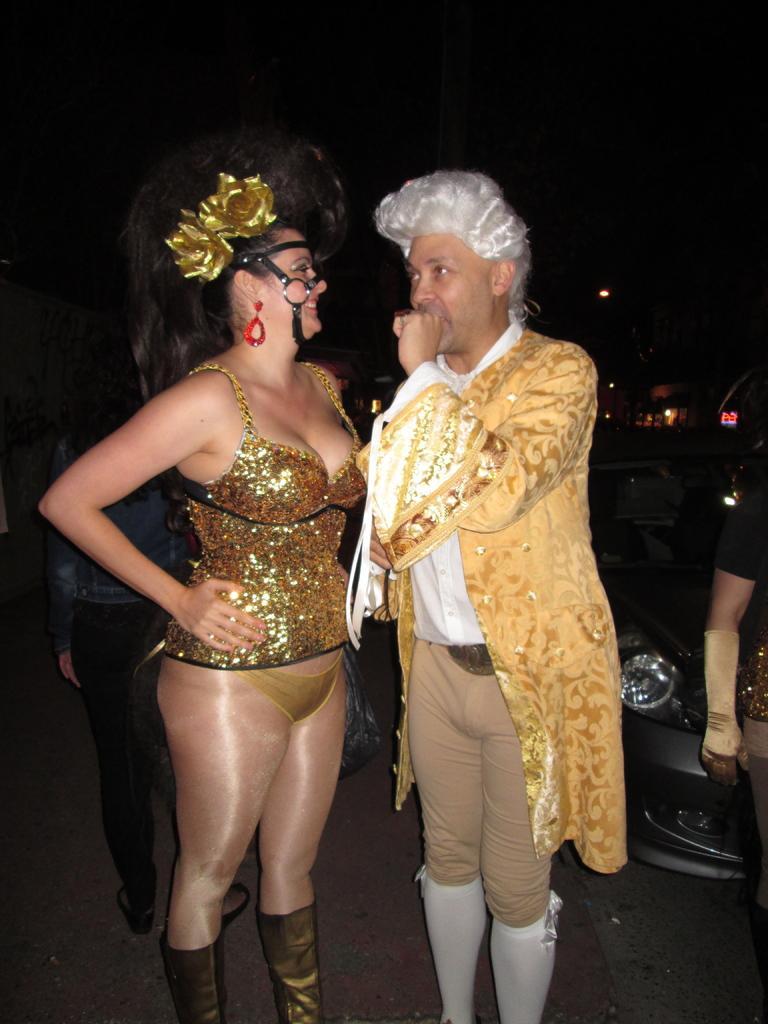Could you give a brief overview of what you see in this image? In this image there are two persons who are standing and on the background there is a car and on the right side and left side there are two persons who are standing. 